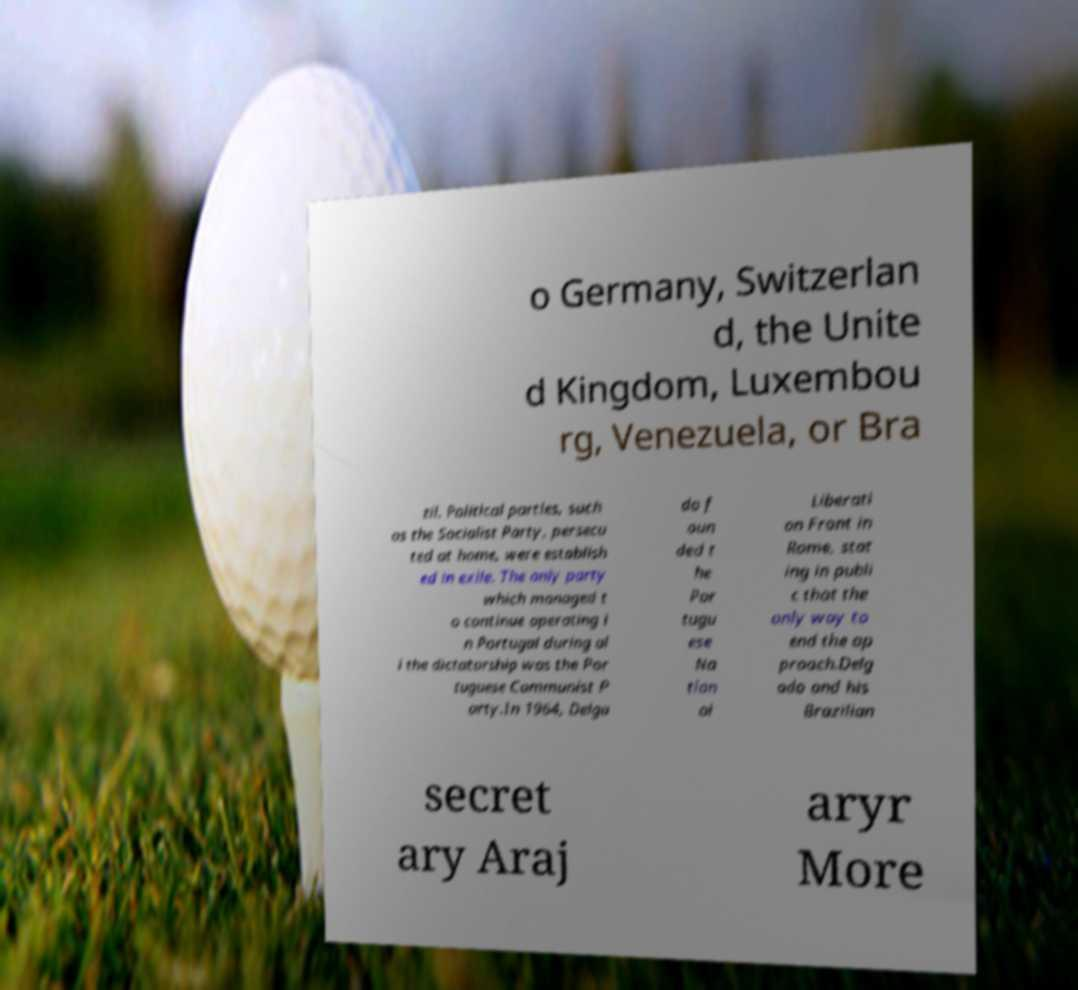Can you read and provide the text displayed in the image?This photo seems to have some interesting text. Can you extract and type it out for me? o Germany, Switzerlan d, the Unite d Kingdom, Luxembou rg, Venezuela, or Bra zil. Political parties, such as the Socialist Party, persecu ted at home, were establish ed in exile. The only party which managed t o continue operating i n Portugal during al l the dictatorship was the Por tuguese Communist P arty.In 1964, Delga do f oun ded t he Por tugu ese Na tion al Liberati on Front in Rome, stat ing in publi c that the only way to end the ap proach.Delg ado and his Brazilian secret ary Araj aryr More 